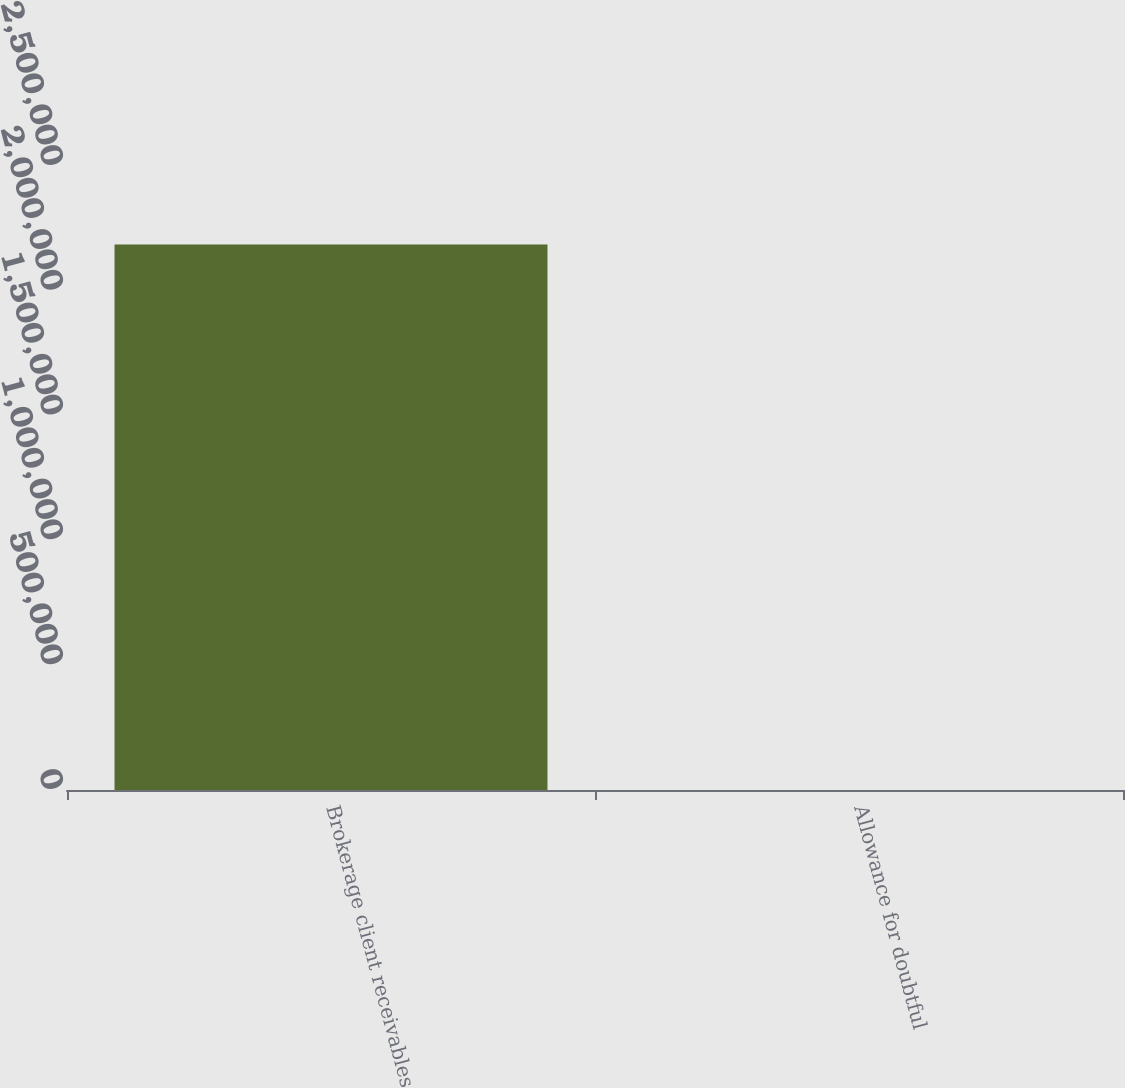Convert chart. <chart><loc_0><loc_0><loc_500><loc_500><bar_chart><fcel>Brokerage client receivables<fcel>Allowance for doubtful<nl><fcel>2.1853e+06<fcel>290<nl></chart> 